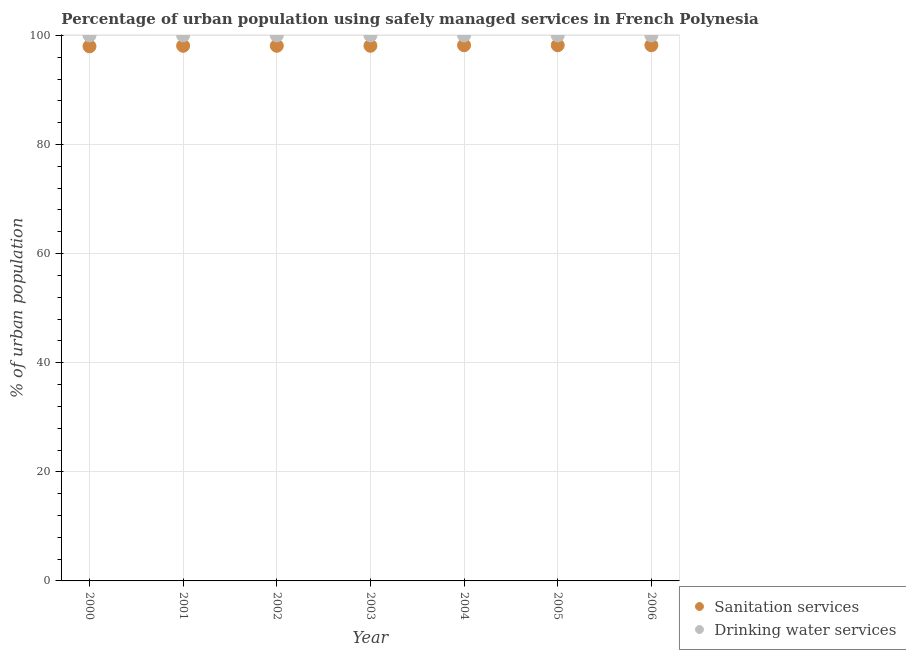How many different coloured dotlines are there?
Your answer should be compact. 2. What is the percentage of urban population who used drinking water services in 2000?
Offer a very short reply. 100. Across all years, what is the maximum percentage of urban population who used drinking water services?
Make the answer very short. 100. Across all years, what is the minimum percentage of urban population who used drinking water services?
Your answer should be very brief. 100. What is the total percentage of urban population who used sanitation services in the graph?
Offer a terse response. 686.9. What is the difference between the percentage of urban population who used sanitation services in 2001 and that in 2005?
Keep it short and to the point. -0.1. What is the difference between the percentage of urban population who used sanitation services in 2003 and the percentage of urban population who used drinking water services in 2006?
Provide a short and direct response. -1.9. In the year 2005, what is the difference between the percentage of urban population who used drinking water services and percentage of urban population who used sanitation services?
Provide a succinct answer. 1.8. In how many years, is the percentage of urban population who used drinking water services greater than 32 %?
Keep it short and to the point. 7. What is the ratio of the percentage of urban population who used drinking water services in 2001 to that in 2006?
Make the answer very short. 1. What is the difference between the highest and the second highest percentage of urban population who used sanitation services?
Make the answer very short. 0. What is the difference between the highest and the lowest percentage of urban population who used sanitation services?
Offer a very short reply. 0.2. Does the percentage of urban population who used sanitation services monotonically increase over the years?
Give a very brief answer. No. Is the percentage of urban population who used drinking water services strictly less than the percentage of urban population who used sanitation services over the years?
Your response must be concise. No. What is the difference between two consecutive major ticks on the Y-axis?
Your answer should be very brief. 20. Does the graph contain grids?
Offer a terse response. Yes. Where does the legend appear in the graph?
Your response must be concise. Bottom right. What is the title of the graph?
Make the answer very short. Percentage of urban population using safely managed services in French Polynesia. Does "Mobile cellular" appear as one of the legend labels in the graph?
Give a very brief answer. No. What is the label or title of the X-axis?
Keep it short and to the point. Year. What is the label or title of the Y-axis?
Provide a short and direct response. % of urban population. What is the % of urban population of Sanitation services in 2000?
Keep it short and to the point. 98. What is the % of urban population in Sanitation services in 2001?
Offer a very short reply. 98.1. What is the % of urban population in Drinking water services in 2001?
Your response must be concise. 100. What is the % of urban population of Sanitation services in 2002?
Give a very brief answer. 98.1. What is the % of urban population of Sanitation services in 2003?
Make the answer very short. 98.1. What is the % of urban population of Sanitation services in 2004?
Give a very brief answer. 98.2. What is the % of urban population of Drinking water services in 2004?
Provide a short and direct response. 100. What is the % of urban population of Sanitation services in 2005?
Provide a succinct answer. 98.2. What is the % of urban population in Drinking water services in 2005?
Offer a terse response. 100. What is the % of urban population in Sanitation services in 2006?
Offer a very short reply. 98.2. What is the % of urban population of Drinking water services in 2006?
Keep it short and to the point. 100. Across all years, what is the maximum % of urban population in Sanitation services?
Ensure brevity in your answer.  98.2. Across all years, what is the maximum % of urban population in Drinking water services?
Keep it short and to the point. 100. Across all years, what is the minimum % of urban population of Sanitation services?
Offer a terse response. 98. Across all years, what is the minimum % of urban population in Drinking water services?
Your answer should be very brief. 100. What is the total % of urban population of Sanitation services in the graph?
Offer a very short reply. 686.9. What is the total % of urban population in Drinking water services in the graph?
Provide a succinct answer. 700. What is the difference between the % of urban population of Drinking water services in 2000 and that in 2002?
Provide a succinct answer. 0. What is the difference between the % of urban population of Drinking water services in 2000 and that in 2004?
Ensure brevity in your answer.  0. What is the difference between the % of urban population of Sanitation services in 2000 and that in 2006?
Provide a short and direct response. -0.2. What is the difference between the % of urban population in Drinking water services in 2000 and that in 2006?
Offer a very short reply. 0. What is the difference between the % of urban population of Drinking water services in 2001 and that in 2004?
Keep it short and to the point. 0. What is the difference between the % of urban population in Sanitation services in 2001 and that in 2005?
Provide a succinct answer. -0.1. What is the difference between the % of urban population in Drinking water services in 2002 and that in 2003?
Your answer should be compact. 0. What is the difference between the % of urban population in Sanitation services in 2002 and that in 2004?
Your response must be concise. -0.1. What is the difference between the % of urban population of Drinking water services in 2002 and that in 2004?
Make the answer very short. 0. What is the difference between the % of urban population in Sanitation services in 2002 and that in 2005?
Your answer should be very brief. -0.1. What is the difference between the % of urban population in Drinking water services in 2002 and that in 2005?
Offer a terse response. 0. What is the difference between the % of urban population of Drinking water services in 2002 and that in 2006?
Your answer should be compact. 0. What is the difference between the % of urban population of Sanitation services in 2003 and that in 2004?
Make the answer very short. -0.1. What is the difference between the % of urban population of Sanitation services in 2003 and that in 2006?
Offer a very short reply. -0.1. What is the difference between the % of urban population in Drinking water services in 2003 and that in 2006?
Provide a short and direct response. 0. What is the difference between the % of urban population of Sanitation services in 2004 and that in 2005?
Offer a terse response. 0. What is the difference between the % of urban population of Drinking water services in 2004 and that in 2006?
Your response must be concise. 0. What is the difference between the % of urban population of Drinking water services in 2005 and that in 2006?
Make the answer very short. 0. What is the difference between the % of urban population of Sanitation services in 2000 and the % of urban population of Drinking water services in 2003?
Your response must be concise. -2. What is the difference between the % of urban population in Sanitation services in 2000 and the % of urban population in Drinking water services in 2006?
Provide a short and direct response. -2. What is the difference between the % of urban population of Sanitation services in 2001 and the % of urban population of Drinking water services in 2002?
Offer a terse response. -1.9. What is the difference between the % of urban population in Sanitation services in 2001 and the % of urban population in Drinking water services in 2005?
Offer a very short reply. -1.9. What is the difference between the % of urban population of Sanitation services in 2002 and the % of urban population of Drinking water services in 2003?
Ensure brevity in your answer.  -1.9. What is the difference between the % of urban population in Sanitation services in 2002 and the % of urban population in Drinking water services in 2005?
Provide a short and direct response. -1.9. What is the difference between the % of urban population in Sanitation services in 2003 and the % of urban population in Drinking water services in 2006?
Your response must be concise. -1.9. What is the average % of urban population of Sanitation services per year?
Provide a succinct answer. 98.13. In the year 2000, what is the difference between the % of urban population of Sanitation services and % of urban population of Drinking water services?
Provide a short and direct response. -2. In the year 2001, what is the difference between the % of urban population in Sanitation services and % of urban population in Drinking water services?
Keep it short and to the point. -1.9. In the year 2002, what is the difference between the % of urban population in Sanitation services and % of urban population in Drinking water services?
Offer a terse response. -1.9. In the year 2003, what is the difference between the % of urban population of Sanitation services and % of urban population of Drinking water services?
Make the answer very short. -1.9. In the year 2004, what is the difference between the % of urban population in Sanitation services and % of urban population in Drinking water services?
Make the answer very short. -1.8. In the year 2005, what is the difference between the % of urban population of Sanitation services and % of urban population of Drinking water services?
Your answer should be very brief. -1.8. What is the ratio of the % of urban population of Drinking water services in 2000 to that in 2001?
Your answer should be very brief. 1. What is the ratio of the % of urban population in Drinking water services in 2000 to that in 2002?
Provide a succinct answer. 1. What is the ratio of the % of urban population in Sanitation services in 2000 to that in 2003?
Your answer should be very brief. 1. What is the ratio of the % of urban population in Drinking water services in 2000 to that in 2003?
Make the answer very short. 1. What is the ratio of the % of urban population in Drinking water services in 2000 to that in 2004?
Keep it short and to the point. 1. What is the ratio of the % of urban population of Drinking water services in 2000 to that in 2005?
Your answer should be very brief. 1. What is the ratio of the % of urban population of Drinking water services in 2000 to that in 2006?
Offer a very short reply. 1. What is the ratio of the % of urban population in Sanitation services in 2001 to that in 2002?
Your response must be concise. 1. What is the ratio of the % of urban population of Drinking water services in 2001 to that in 2002?
Offer a very short reply. 1. What is the ratio of the % of urban population of Sanitation services in 2001 to that in 2004?
Ensure brevity in your answer.  1. What is the ratio of the % of urban population in Drinking water services in 2001 to that in 2004?
Provide a short and direct response. 1. What is the ratio of the % of urban population in Drinking water services in 2001 to that in 2006?
Your answer should be compact. 1. What is the ratio of the % of urban population of Sanitation services in 2002 to that in 2003?
Ensure brevity in your answer.  1. What is the ratio of the % of urban population in Drinking water services in 2002 to that in 2003?
Offer a very short reply. 1. What is the ratio of the % of urban population of Drinking water services in 2002 to that in 2004?
Your answer should be very brief. 1. What is the ratio of the % of urban population of Sanitation services in 2002 to that in 2005?
Keep it short and to the point. 1. What is the ratio of the % of urban population in Drinking water services in 2002 to that in 2005?
Offer a terse response. 1. What is the ratio of the % of urban population of Sanitation services in 2002 to that in 2006?
Your response must be concise. 1. What is the ratio of the % of urban population of Sanitation services in 2003 to that in 2005?
Keep it short and to the point. 1. What is the ratio of the % of urban population in Drinking water services in 2003 to that in 2005?
Offer a very short reply. 1. What is the ratio of the % of urban population of Sanitation services in 2004 to that in 2005?
Give a very brief answer. 1. What is the ratio of the % of urban population of Drinking water services in 2004 to that in 2005?
Keep it short and to the point. 1. What is the difference between the highest and the second highest % of urban population in Sanitation services?
Offer a very short reply. 0. What is the difference between the highest and the lowest % of urban population of Drinking water services?
Provide a succinct answer. 0. 